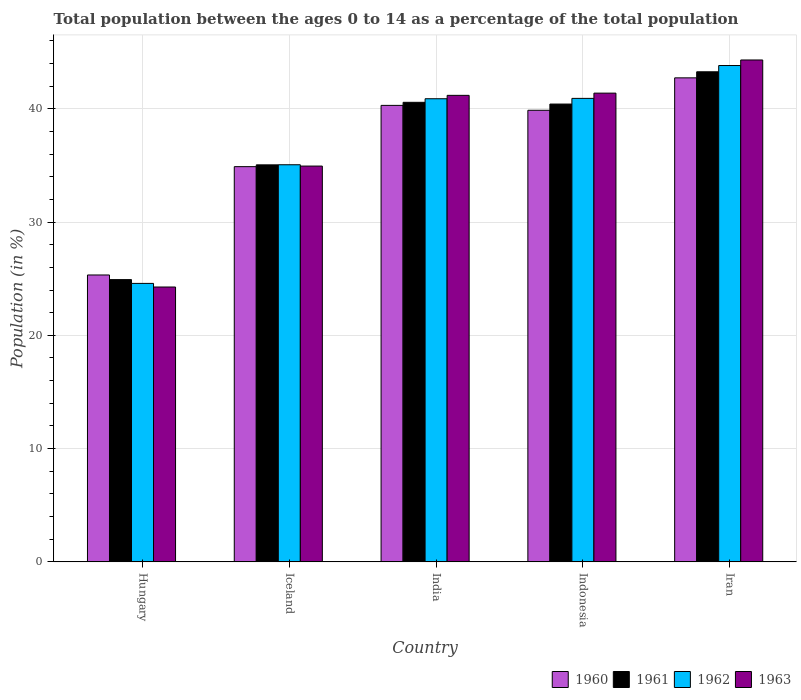How many different coloured bars are there?
Provide a succinct answer. 4. How many groups of bars are there?
Give a very brief answer. 5. Are the number of bars on each tick of the X-axis equal?
Give a very brief answer. Yes. What is the label of the 4th group of bars from the left?
Keep it short and to the point. Indonesia. In how many cases, is the number of bars for a given country not equal to the number of legend labels?
Your answer should be compact. 0. What is the percentage of the population ages 0 to 14 in 1962 in Indonesia?
Make the answer very short. 40.92. Across all countries, what is the maximum percentage of the population ages 0 to 14 in 1961?
Make the answer very short. 43.27. Across all countries, what is the minimum percentage of the population ages 0 to 14 in 1960?
Provide a short and direct response. 25.33. In which country was the percentage of the population ages 0 to 14 in 1960 maximum?
Make the answer very short. Iran. In which country was the percentage of the population ages 0 to 14 in 1961 minimum?
Offer a very short reply. Hungary. What is the total percentage of the population ages 0 to 14 in 1960 in the graph?
Ensure brevity in your answer.  183.12. What is the difference between the percentage of the population ages 0 to 14 in 1960 in India and that in Iran?
Give a very brief answer. -2.43. What is the difference between the percentage of the population ages 0 to 14 in 1961 in Iceland and the percentage of the population ages 0 to 14 in 1960 in Hungary?
Make the answer very short. 9.72. What is the average percentage of the population ages 0 to 14 in 1962 per country?
Make the answer very short. 37.05. What is the difference between the percentage of the population ages 0 to 14 of/in 1962 and percentage of the population ages 0 to 14 of/in 1960 in India?
Offer a very short reply. 0.59. In how many countries, is the percentage of the population ages 0 to 14 in 1963 greater than 22?
Give a very brief answer. 5. What is the ratio of the percentage of the population ages 0 to 14 in 1961 in Iceland to that in Indonesia?
Provide a short and direct response. 0.87. What is the difference between the highest and the second highest percentage of the population ages 0 to 14 in 1960?
Keep it short and to the point. -2.43. What is the difference between the highest and the lowest percentage of the population ages 0 to 14 in 1963?
Provide a short and direct response. 20.04. Is the sum of the percentage of the population ages 0 to 14 in 1962 in Hungary and Iran greater than the maximum percentage of the population ages 0 to 14 in 1960 across all countries?
Your answer should be very brief. Yes. Is it the case that in every country, the sum of the percentage of the population ages 0 to 14 in 1963 and percentage of the population ages 0 to 14 in 1962 is greater than the sum of percentage of the population ages 0 to 14 in 1961 and percentage of the population ages 0 to 14 in 1960?
Provide a short and direct response. No. What does the 4th bar from the left in Iceland represents?
Give a very brief answer. 1963. Are all the bars in the graph horizontal?
Ensure brevity in your answer.  No. Are the values on the major ticks of Y-axis written in scientific E-notation?
Give a very brief answer. No. Does the graph contain any zero values?
Give a very brief answer. No. How many legend labels are there?
Your answer should be compact. 4. How are the legend labels stacked?
Make the answer very short. Horizontal. What is the title of the graph?
Ensure brevity in your answer.  Total population between the ages 0 to 14 as a percentage of the total population. Does "1965" appear as one of the legend labels in the graph?
Offer a terse response. No. What is the Population (in %) in 1960 in Hungary?
Provide a succinct answer. 25.33. What is the Population (in %) in 1961 in Hungary?
Offer a terse response. 24.92. What is the Population (in %) in 1962 in Hungary?
Your answer should be compact. 24.59. What is the Population (in %) in 1963 in Hungary?
Make the answer very short. 24.27. What is the Population (in %) of 1960 in Iceland?
Keep it short and to the point. 34.89. What is the Population (in %) of 1961 in Iceland?
Give a very brief answer. 35.05. What is the Population (in %) in 1962 in Iceland?
Keep it short and to the point. 35.06. What is the Population (in %) in 1963 in Iceland?
Provide a short and direct response. 34.94. What is the Population (in %) of 1960 in India?
Ensure brevity in your answer.  40.3. What is the Population (in %) in 1961 in India?
Your answer should be compact. 40.57. What is the Population (in %) of 1962 in India?
Make the answer very short. 40.89. What is the Population (in %) in 1963 in India?
Provide a succinct answer. 41.19. What is the Population (in %) in 1960 in Indonesia?
Offer a terse response. 39.87. What is the Population (in %) of 1961 in Indonesia?
Keep it short and to the point. 40.42. What is the Population (in %) in 1962 in Indonesia?
Your answer should be compact. 40.92. What is the Population (in %) of 1963 in Indonesia?
Make the answer very short. 41.38. What is the Population (in %) of 1960 in Iran?
Your response must be concise. 42.73. What is the Population (in %) of 1961 in Iran?
Offer a terse response. 43.27. What is the Population (in %) in 1962 in Iran?
Provide a succinct answer. 43.82. What is the Population (in %) of 1963 in Iran?
Your response must be concise. 44.31. Across all countries, what is the maximum Population (in %) in 1960?
Give a very brief answer. 42.73. Across all countries, what is the maximum Population (in %) of 1961?
Provide a short and direct response. 43.27. Across all countries, what is the maximum Population (in %) in 1962?
Your answer should be very brief. 43.82. Across all countries, what is the maximum Population (in %) of 1963?
Your answer should be compact. 44.31. Across all countries, what is the minimum Population (in %) of 1960?
Your answer should be very brief. 25.33. Across all countries, what is the minimum Population (in %) of 1961?
Make the answer very short. 24.92. Across all countries, what is the minimum Population (in %) in 1962?
Ensure brevity in your answer.  24.59. Across all countries, what is the minimum Population (in %) of 1963?
Offer a very short reply. 24.27. What is the total Population (in %) in 1960 in the graph?
Provide a short and direct response. 183.12. What is the total Population (in %) of 1961 in the graph?
Give a very brief answer. 184.23. What is the total Population (in %) in 1962 in the graph?
Offer a terse response. 185.27. What is the total Population (in %) in 1963 in the graph?
Keep it short and to the point. 186.09. What is the difference between the Population (in %) of 1960 in Hungary and that in Iceland?
Your answer should be compact. -9.56. What is the difference between the Population (in %) of 1961 in Hungary and that in Iceland?
Your response must be concise. -10.13. What is the difference between the Population (in %) of 1962 in Hungary and that in Iceland?
Your answer should be compact. -10.47. What is the difference between the Population (in %) of 1963 in Hungary and that in Iceland?
Ensure brevity in your answer.  -10.68. What is the difference between the Population (in %) in 1960 in Hungary and that in India?
Offer a terse response. -14.97. What is the difference between the Population (in %) in 1961 in Hungary and that in India?
Make the answer very short. -15.65. What is the difference between the Population (in %) of 1962 in Hungary and that in India?
Give a very brief answer. -16.3. What is the difference between the Population (in %) of 1963 in Hungary and that in India?
Your answer should be compact. -16.92. What is the difference between the Population (in %) in 1960 in Hungary and that in Indonesia?
Give a very brief answer. -14.54. What is the difference between the Population (in %) of 1961 in Hungary and that in Indonesia?
Offer a terse response. -15.5. What is the difference between the Population (in %) in 1962 in Hungary and that in Indonesia?
Offer a terse response. -16.33. What is the difference between the Population (in %) in 1963 in Hungary and that in Indonesia?
Your answer should be very brief. -17.12. What is the difference between the Population (in %) in 1960 in Hungary and that in Iran?
Offer a very short reply. -17.4. What is the difference between the Population (in %) in 1961 in Hungary and that in Iran?
Offer a terse response. -18.35. What is the difference between the Population (in %) of 1962 in Hungary and that in Iran?
Make the answer very short. -19.24. What is the difference between the Population (in %) of 1963 in Hungary and that in Iran?
Offer a very short reply. -20.04. What is the difference between the Population (in %) of 1960 in Iceland and that in India?
Provide a succinct answer. -5.41. What is the difference between the Population (in %) of 1961 in Iceland and that in India?
Your answer should be compact. -5.52. What is the difference between the Population (in %) in 1962 in Iceland and that in India?
Make the answer very short. -5.83. What is the difference between the Population (in %) of 1963 in Iceland and that in India?
Your answer should be compact. -6.24. What is the difference between the Population (in %) of 1960 in Iceland and that in Indonesia?
Ensure brevity in your answer.  -4.98. What is the difference between the Population (in %) in 1961 in Iceland and that in Indonesia?
Make the answer very short. -5.37. What is the difference between the Population (in %) in 1962 in Iceland and that in Indonesia?
Provide a short and direct response. -5.86. What is the difference between the Population (in %) of 1963 in Iceland and that in Indonesia?
Offer a very short reply. -6.44. What is the difference between the Population (in %) of 1960 in Iceland and that in Iran?
Keep it short and to the point. -7.84. What is the difference between the Population (in %) of 1961 in Iceland and that in Iran?
Your answer should be compact. -8.22. What is the difference between the Population (in %) of 1962 in Iceland and that in Iran?
Make the answer very short. -8.76. What is the difference between the Population (in %) of 1963 in Iceland and that in Iran?
Offer a very short reply. -9.37. What is the difference between the Population (in %) in 1960 in India and that in Indonesia?
Your answer should be very brief. 0.43. What is the difference between the Population (in %) in 1961 in India and that in Indonesia?
Provide a succinct answer. 0.15. What is the difference between the Population (in %) of 1962 in India and that in Indonesia?
Give a very brief answer. -0.03. What is the difference between the Population (in %) of 1963 in India and that in Indonesia?
Offer a terse response. -0.2. What is the difference between the Population (in %) in 1960 in India and that in Iran?
Keep it short and to the point. -2.43. What is the difference between the Population (in %) in 1961 in India and that in Iran?
Provide a short and direct response. -2.7. What is the difference between the Population (in %) of 1962 in India and that in Iran?
Offer a terse response. -2.93. What is the difference between the Population (in %) in 1963 in India and that in Iran?
Provide a succinct answer. -3.12. What is the difference between the Population (in %) in 1960 in Indonesia and that in Iran?
Offer a very short reply. -2.86. What is the difference between the Population (in %) of 1961 in Indonesia and that in Iran?
Your response must be concise. -2.85. What is the difference between the Population (in %) of 1962 in Indonesia and that in Iran?
Provide a short and direct response. -2.9. What is the difference between the Population (in %) in 1963 in Indonesia and that in Iran?
Give a very brief answer. -2.93. What is the difference between the Population (in %) in 1960 in Hungary and the Population (in %) in 1961 in Iceland?
Your response must be concise. -9.72. What is the difference between the Population (in %) in 1960 in Hungary and the Population (in %) in 1962 in Iceland?
Make the answer very short. -9.73. What is the difference between the Population (in %) in 1960 in Hungary and the Population (in %) in 1963 in Iceland?
Make the answer very short. -9.61. What is the difference between the Population (in %) of 1961 in Hungary and the Population (in %) of 1962 in Iceland?
Your response must be concise. -10.14. What is the difference between the Population (in %) of 1961 in Hungary and the Population (in %) of 1963 in Iceland?
Make the answer very short. -10.02. What is the difference between the Population (in %) in 1962 in Hungary and the Population (in %) in 1963 in Iceland?
Offer a terse response. -10.36. What is the difference between the Population (in %) of 1960 in Hungary and the Population (in %) of 1961 in India?
Your response must be concise. -15.24. What is the difference between the Population (in %) of 1960 in Hungary and the Population (in %) of 1962 in India?
Give a very brief answer. -15.56. What is the difference between the Population (in %) in 1960 in Hungary and the Population (in %) in 1963 in India?
Give a very brief answer. -15.86. What is the difference between the Population (in %) in 1961 in Hungary and the Population (in %) in 1962 in India?
Offer a very short reply. -15.97. What is the difference between the Population (in %) in 1961 in Hungary and the Population (in %) in 1963 in India?
Give a very brief answer. -16.27. What is the difference between the Population (in %) of 1962 in Hungary and the Population (in %) of 1963 in India?
Your answer should be compact. -16.6. What is the difference between the Population (in %) of 1960 in Hungary and the Population (in %) of 1961 in Indonesia?
Offer a terse response. -15.09. What is the difference between the Population (in %) in 1960 in Hungary and the Population (in %) in 1962 in Indonesia?
Give a very brief answer. -15.59. What is the difference between the Population (in %) of 1960 in Hungary and the Population (in %) of 1963 in Indonesia?
Make the answer very short. -16.05. What is the difference between the Population (in %) in 1961 in Hungary and the Population (in %) in 1962 in Indonesia?
Your answer should be very brief. -16. What is the difference between the Population (in %) in 1961 in Hungary and the Population (in %) in 1963 in Indonesia?
Ensure brevity in your answer.  -16.46. What is the difference between the Population (in %) of 1962 in Hungary and the Population (in %) of 1963 in Indonesia?
Your answer should be compact. -16.8. What is the difference between the Population (in %) of 1960 in Hungary and the Population (in %) of 1961 in Iran?
Your answer should be compact. -17.94. What is the difference between the Population (in %) of 1960 in Hungary and the Population (in %) of 1962 in Iran?
Your answer should be compact. -18.49. What is the difference between the Population (in %) of 1960 in Hungary and the Population (in %) of 1963 in Iran?
Offer a terse response. -18.98. What is the difference between the Population (in %) of 1961 in Hungary and the Population (in %) of 1962 in Iran?
Give a very brief answer. -18.9. What is the difference between the Population (in %) of 1961 in Hungary and the Population (in %) of 1963 in Iran?
Ensure brevity in your answer.  -19.39. What is the difference between the Population (in %) of 1962 in Hungary and the Population (in %) of 1963 in Iran?
Ensure brevity in your answer.  -19.73. What is the difference between the Population (in %) in 1960 in Iceland and the Population (in %) in 1961 in India?
Offer a very short reply. -5.68. What is the difference between the Population (in %) in 1960 in Iceland and the Population (in %) in 1962 in India?
Your answer should be very brief. -6. What is the difference between the Population (in %) of 1960 in Iceland and the Population (in %) of 1963 in India?
Ensure brevity in your answer.  -6.29. What is the difference between the Population (in %) of 1961 in Iceland and the Population (in %) of 1962 in India?
Make the answer very short. -5.84. What is the difference between the Population (in %) in 1961 in Iceland and the Population (in %) in 1963 in India?
Ensure brevity in your answer.  -6.14. What is the difference between the Population (in %) in 1962 in Iceland and the Population (in %) in 1963 in India?
Offer a terse response. -6.13. What is the difference between the Population (in %) of 1960 in Iceland and the Population (in %) of 1961 in Indonesia?
Your answer should be compact. -5.53. What is the difference between the Population (in %) in 1960 in Iceland and the Population (in %) in 1962 in Indonesia?
Give a very brief answer. -6.03. What is the difference between the Population (in %) in 1960 in Iceland and the Population (in %) in 1963 in Indonesia?
Your response must be concise. -6.49. What is the difference between the Population (in %) of 1961 in Iceland and the Population (in %) of 1962 in Indonesia?
Keep it short and to the point. -5.87. What is the difference between the Population (in %) of 1961 in Iceland and the Population (in %) of 1963 in Indonesia?
Make the answer very short. -6.33. What is the difference between the Population (in %) in 1962 in Iceland and the Population (in %) in 1963 in Indonesia?
Provide a short and direct response. -6.32. What is the difference between the Population (in %) of 1960 in Iceland and the Population (in %) of 1961 in Iran?
Keep it short and to the point. -8.38. What is the difference between the Population (in %) of 1960 in Iceland and the Population (in %) of 1962 in Iran?
Your answer should be very brief. -8.93. What is the difference between the Population (in %) of 1960 in Iceland and the Population (in %) of 1963 in Iran?
Provide a short and direct response. -9.42. What is the difference between the Population (in %) in 1961 in Iceland and the Population (in %) in 1962 in Iran?
Your response must be concise. -8.77. What is the difference between the Population (in %) in 1961 in Iceland and the Population (in %) in 1963 in Iran?
Keep it short and to the point. -9.26. What is the difference between the Population (in %) of 1962 in Iceland and the Population (in %) of 1963 in Iran?
Give a very brief answer. -9.25. What is the difference between the Population (in %) of 1960 in India and the Population (in %) of 1961 in Indonesia?
Provide a short and direct response. -0.12. What is the difference between the Population (in %) in 1960 in India and the Population (in %) in 1962 in Indonesia?
Offer a very short reply. -0.62. What is the difference between the Population (in %) of 1960 in India and the Population (in %) of 1963 in Indonesia?
Offer a very short reply. -1.08. What is the difference between the Population (in %) in 1961 in India and the Population (in %) in 1962 in Indonesia?
Your response must be concise. -0.35. What is the difference between the Population (in %) in 1961 in India and the Population (in %) in 1963 in Indonesia?
Offer a very short reply. -0.81. What is the difference between the Population (in %) of 1962 in India and the Population (in %) of 1963 in Indonesia?
Offer a terse response. -0.49. What is the difference between the Population (in %) in 1960 in India and the Population (in %) in 1961 in Iran?
Offer a terse response. -2.97. What is the difference between the Population (in %) in 1960 in India and the Population (in %) in 1962 in Iran?
Make the answer very short. -3.52. What is the difference between the Population (in %) in 1960 in India and the Population (in %) in 1963 in Iran?
Keep it short and to the point. -4.01. What is the difference between the Population (in %) of 1961 in India and the Population (in %) of 1962 in Iran?
Offer a terse response. -3.25. What is the difference between the Population (in %) of 1961 in India and the Population (in %) of 1963 in Iran?
Offer a terse response. -3.74. What is the difference between the Population (in %) in 1962 in India and the Population (in %) in 1963 in Iran?
Your answer should be very brief. -3.42. What is the difference between the Population (in %) of 1960 in Indonesia and the Population (in %) of 1961 in Iran?
Your response must be concise. -3.4. What is the difference between the Population (in %) of 1960 in Indonesia and the Population (in %) of 1962 in Iran?
Make the answer very short. -3.95. What is the difference between the Population (in %) of 1960 in Indonesia and the Population (in %) of 1963 in Iran?
Make the answer very short. -4.44. What is the difference between the Population (in %) in 1961 in Indonesia and the Population (in %) in 1962 in Iran?
Keep it short and to the point. -3.4. What is the difference between the Population (in %) of 1961 in Indonesia and the Population (in %) of 1963 in Iran?
Offer a very short reply. -3.89. What is the difference between the Population (in %) in 1962 in Indonesia and the Population (in %) in 1963 in Iran?
Your answer should be very brief. -3.39. What is the average Population (in %) in 1960 per country?
Offer a terse response. 36.62. What is the average Population (in %) in 1961 per country?
Make the answer very short. 36.85. What is the average Population (in %) of 1962 per country?
Your answer should be very brief. 37.05. What is the average Population (in %) in 1963 per country?
Ensure brevity in your answer.  37.22. What is the difference between the Population (in %) of 1960 and Population (in %) of 1961 in Hungary?
Make the answer very short. 0.41. What is the difference between the Population (in %) of 1960 and Population (in %) of 1962 in Hungary?
Give a very brief answer. 0.74. What is the difference between the Population (in %) of 1960 and Population (in %) of 1963 in Hungary?
Your response must be concise. 1.06. What is the difference between the Population (in %) in 1961 and Population (in %) in 1962 in Hungary?
Give a very brief answer. 0.33. What is the difference between the Population (in %) of 1961 and Population (in %) of 1963 in Hungary?
Ensure brevity in your answer.  0.65. What is the difference between the Population (in %) in 1962 and Population (in %) in 1963 in Hungary?
Ensure brevity in your answer.  0.32. What is the difference between the Population (in %) of 1960 and Population (in %) of 1961 in Iceland?
Make the answer very short. -0.16. What is the difference between the Population (in %) in 1960 and Population (in %) in 1962 in Iceland?
Ensure brevity in your answer.  -0.17. What is the difference between the Population (in %) of 1960 and Population (in %) of 1963 in Iceland?
Offer a very short reply. -0.05. What is the difference between the Population (in %) in 1961 and Population (in %) in 1962 in Iceland?
Provide a short and direct response. -0.01. What is the difference between the Population (in %) in 1961 and Population (in %) in 1963 in Iceland?
Keep it short and to the point. 0.11. What is the difference between the Population (in %) of 1962 and Population (in %) of 1963 in Iceland?
Make the answer very short. 0.12. What is the difference between the Population (in %) in 1960 and Population (in %) in 1961 in India?
Your answer should be compact. -0.27. What is the difference between the Population (in %) in 1960 and Population (in %) in 1962 in India?
Give a very brief answer. -0.59. What is the difference between the Population (in %) in 1960 and Population (in %) in 1963 in India?
Ensure brevity in your answer.  -0.89. What is the difference between the Population (in %) in 1961 and Population (in %) in 1962 in India?
Your response must be concise. -0.32. What is the difference between the Population (in %) of 1961 and Population (in %) of 1963 in India?
Keep it short and to the point. -0.62. What is the difference between the Population (in %) in 1962 and Population (in %) in 1963 in India?
Your response must be concise. -0.3. What is the difference between the Population (in %) of 1960 and Population (in %) of 1961 in Indonesia?
Ensure brevity in your answer.  -0.55. What is the difference between the Population (in %) of 1960 and Population (in %) of 1962 in Indonesia?
Offer a terse response. -1.05. What is the difference between the Population (in %) of 1960 and Population (in %) of 1963 in Indonesia?
Give a very brief answer. -1.51. What is the difference between the Population (in %) of 1961 and Population (in %) of 1962 in Indonesia?
Make the answer very short. -0.5. What is the difference between the Population (in %) in 1961 and Population (in %) in 1963 in Indonesia?
Offer a very short reply. -0.96. What is the difference between the Population (in %) of 1962 and Population (in %) of 1963 in Indonesia?
Provide a short and direct response. -0.46. What is the difference between the Population (in %) in 1960 and Population (in %) in 1961 in Iran?
Offer a terse response. -0.54. What is the difference between the Population (in %) in 1960 and Population (in %) in 1962 in Iran?
Ensure brevity in your answer.  -1.09. What is the difference between the Population (in %) of 1960 and Population (in %) of 1963 in Iran?
Offer a very short reply. -1.58. What is the difference between the Population (in %) in 1961 and Population (in %) in 1962 in Iran?
Provide a succinct answer. -0.55. What is the difference between the Population (in %) in 1961 and Population (in %) in 1963 in Iran?
Keep it short and to the point. -1.04. What is the difference between the Population (in %) in 1962 and Population (in %) in 1963 in Iran?
Offer a very short reply. -0.49. What is the ratio of the Population (in %) of 1960 in Hungary to that in Iceland?
Give a very brief answer. 0.73. What is the ratio of the Population (in %) in 1961 in Hungary to that in Iceland?
Make the answer very short. 0.71. What is the ratio of the Population (in %) of 1962 in Hungary to that in Iceland?
Provide a short and direct response. 0.7. What is the ratio of the Population (in %) of 1963 in Hungary to that in Iceland?
Offer a very short reply. 0.69. What is the ratio of the Population (in %) in 1960 in Hungary to that in India?
Make the answer very short. 0.63. What is the ratio of the Population (in %) in 1961 in Hungary to that in India?
Offer a very short reply. 0.61. What is the ratio of the Population (in %) of 1962 in Hungary to that in India?
Your response must be concise. 0.6. What is the ratio of the Population (in %) of 1963 in Hungary to that in India?
Make the answer very short. 0.59. What is the ratio of the Population (in %) of 1960 in Hungary to that in Indonesia?
Your response must be concise. 0.64. What is the ratio of the Population (in %) of 1961 in Hungary to that in Indonesia?
Provide a succinct answer. 0.62. What is the ratio of the Population (in %) of 1962 in Hungary to that in Indonesia?
Keep it short and to the point. 0.6. What is the ratio of the Population (in %) of 1963 in Hungary to that in Indonesia?
Your response must be concise. 0.59. What is the ratio of the Population (in %) of 1960 in Hungary to that in Iran?
Ensure brevity in your answer.  0.59. What is the ratio of the Population (in %) in 1961 in Hungary to that in Iran?
Offer a very short reply. 0.58. What is the ratio of the Population (in %) of 1962 in Hungary to that in Iran?
Provide a succinct answer. 0.56. What is the ratio of the Population (in %) of 1963 in Hungary to that in Iran?
Ensure brevity in your answer.  0.55. What is the ratio of the Population (in %) in 1960 in Iceland to that in India?
Your answer should be compact. 0.87. What is the ratio of the Population (in %) of 1961 in Iceland to that in India?
Your answer should be very brief. 0.86. What is the ratio of the Population (in %) of 1962 in Iceland to that in India?
Provide a succinct answer. 0.86. What is the ratio of the Population (in %) of 1963 in Iceland to that in India?
Offer a terse response. 0.85. What is the ratio of the Population (in %) in 1960 in Iceland to that in Indonesia?
Offer a terse response. 0.88. What is the ratio of the Population (in %) in 1961 in Iceland to that in Indonesia?
Make the answer very short. 0.87. What is the ratio of the Population (in %) in 1962 in Iceland to that in Indonesia?
Your answer should be compact. 0.86. What is the ratio of the Population (in %) in 1963 in Iceland to that in Indonesia?
Provide a short and direct response. 0.84. What is the ratio of the Population (in %) of 1960 in Iceland to that in Iran?
Your response must be concise. 0.82. What is the ratio of the Population (in %) of 1961 in Iceland to that in Iran?
Your answer should be very brief. 0.81. What is the ratio of the Population (in %) of 1962 in Iceland to that in Iran?
Ensure brevity in your answer.  0.8. What is the ratio of the Population (in %) of 1963 in Iceland to that in Iran?
Your response must be concise. 0.79. What is the ratio of the Population (in %) of 1960 in India to that in Indonesia?
Your response must be concise. 1.01. What is the ratio of the Population (in %) in 1963 in India to that in Indonesia?
Give a very brief answer. 1. What is the ratio of the Population (in %) of 1960 in India to that in Iran?
Offer a terse response. 0.94. What is the ratio of the Population (in %) in 1961 in India to that in Iran?
Your answer should be very brief. 0.94. What is the ratio of the Population (in %) of 1962 in India to that in Iran?
Make the answer very short. 0.93. What is the ratio of the Population (in %) of 1963 in India to that in Iran?
Ensure brevity in your answer.  0.93. What is the ratio of the Population (in %) in 1960 in Indonesia to that in Iran?
Give a very brief answer. 0.93. What is the ratio of the Population (in %) in 1961 in Indonesia to that in Iran?
Provide a short and direct response. 0.93. What is the ratio of the Population (in %) of 1962 in Indonesia to that in Iran?
Keep it short and to the point. 0.93. What is the ratio of the Population (in %) of 1963 in Indonesia to that in Iran?
Your answer should be compact. 0.93. What is the difference between the highest and the second highest Population (in %) in 1960?
Make the answer very short. 2.43. What is the difference between the highest and the second highest Population (in %) of 1961?
Ensure brevity in your answer.  2.7. What is the difference between the highest and the second highest Population (in %) in 1962?
Offer a very short reply. 2.9. What is the difference between the highest and the second highest Population (in %) of 1963?
Give a very brief answer. 2.93. What is the difference between the highest and the lowest Population (in %) of 1960?
Offer a terse response. 17.4. What is the difference between the highest and the lowest Population (in %) of 1961?
Provide a short and direct response. 18.35. What is the difference between the highest and the lowest Population (in %) in 1962?
Offer a terse response. 19.24. What is the difference between the highest and the lowest Population (in %) of 1963?
Provide a succinct answer. 20.04. 